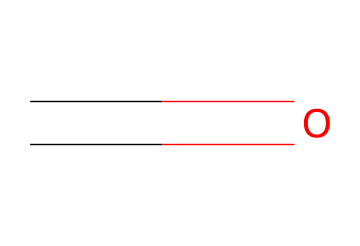What is the molecular formula of formaldehyde? The SMILES representation shows one carbon atom (C) and one oxygen atom (O), giving a molecular formula of CH2O.
Answer: CH2O How many hydrogen atoms are present in the structure? The structure has one carbon atom connected to one oxygen atom, and it follows the formula CH2O, which indicates there are two hydrogen atoms.
Answer: 2 What type of bond is present between the carbon and oxygen in formaldehyde? In the SMILES representation, the notation "C=O" indicates a double bond between the carbon (C) and oxygen (O) atoms.
Answer: double bond What functional group characterizes formaldehyde? The presence of the carbonyl group (C=O) at the end of the carbon chain indicates that this molecule has an aldehyde functional group.
Answer: aldehyde What is the relationship between formaldehyde and household cleaners? Formaldehyde is often used as a disinfectant and preservative in various household cleaners due to its antimicrobial properties.
Answer: disinfectant How does the chemical structure of formaldehyde relate to its reactivity? The presence of the carbonyl functional group (C=O) makes formaldehyde reactive with nucleophiles, which is typical for aldehydes and contributes to its applications.
Answer: reactive 